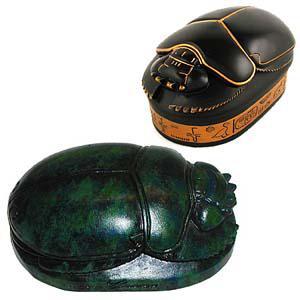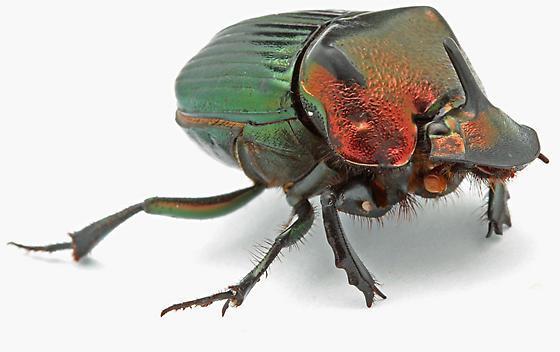The first image is the image on the left, the second image is the image on the right. For the images shown, is this caption "At least one image shows a single beetle that is iridescent green with iridescent red highlights." true? Answer yes or no. Yes. 